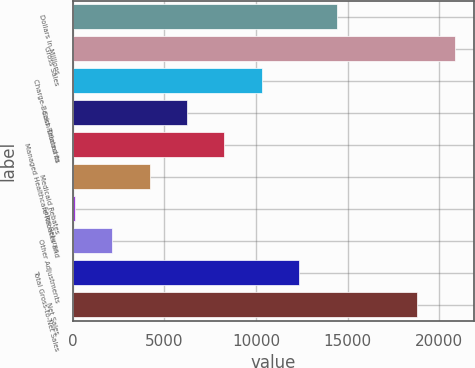Convert chart to OTSL. <chart><loc_0><loc_0><loc_500><loc_500><bar_chart><fcel>Dollars in Millions<fcel>Gross Sales<fcel>Charge-Backs Related to<fcel>Cash Discounts<fcel>Managed Healthcare Rebates and<fcel>Medicaid Rebates<fcel>Sales Returns<fcel>Other Adjustments<fcel>Total Gross-to-Net Sales<fcel>Net Sales<nl><fcel>14418.8<fcel>20853.4<fcel>10328<fcel>6237.2<fcel>8282.6<fcel>4191.8<fcel>101<fcel>2146.4<fcel>12373.4<fcel>18808<nl></chart> 